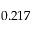Convert formula to latex. <formula><loc_0><loc_0><loc_500><loc_500>0 . 2 1 7</formula> 